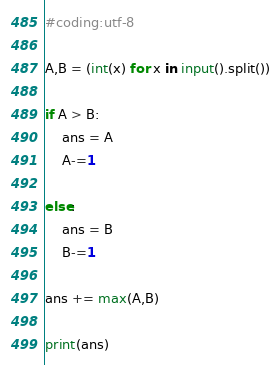Convert code to text. <code><loc_0><loc_0><loc_500><loc_500><_Python_>#coding:utf-8

A,B = (int(x) for x in input().split())

if A > B:
	ans = A
	A-=1
	
else:
	ans = B
	B-=1
	
ans += max(A,B)

print(ans)</code> 